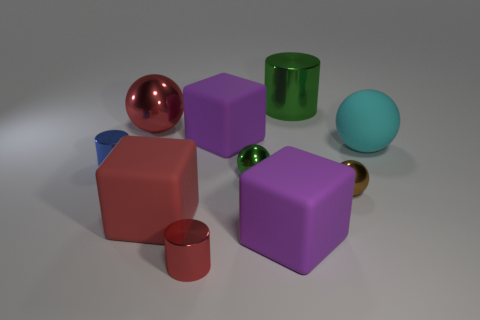Subtract 1 spheres. How many spheres are left? 3 Subtract all cylinders. How many objects are left? 7 Add 3 red cylinders. How many red cylinders are left? 4 Add 1 big green rubber cylinders. How many big green rubber cylinders exist? 1 Subtract 0 yellow balls. How many objects are left? 10 Subtract all big purple matte blocks. Subtract all large red rubber cubes. How many objects are left? 7 